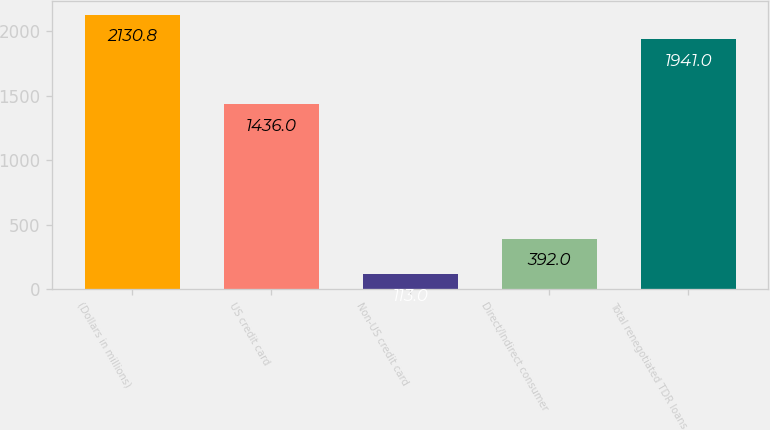<chart> <loc_0><loc_0><loc_500><loc_500><bar_chart><fcel>(Dollars in millions)<fcel>US credit card<fcel>Non-US credit card<fcel>Direct/Indirect consumer<fcel>Total renegotiated TDR loans<nl><fcel>2130.8<fcel>1436<fcel>113<fcel>392<fcel>1941<nl></chart> 